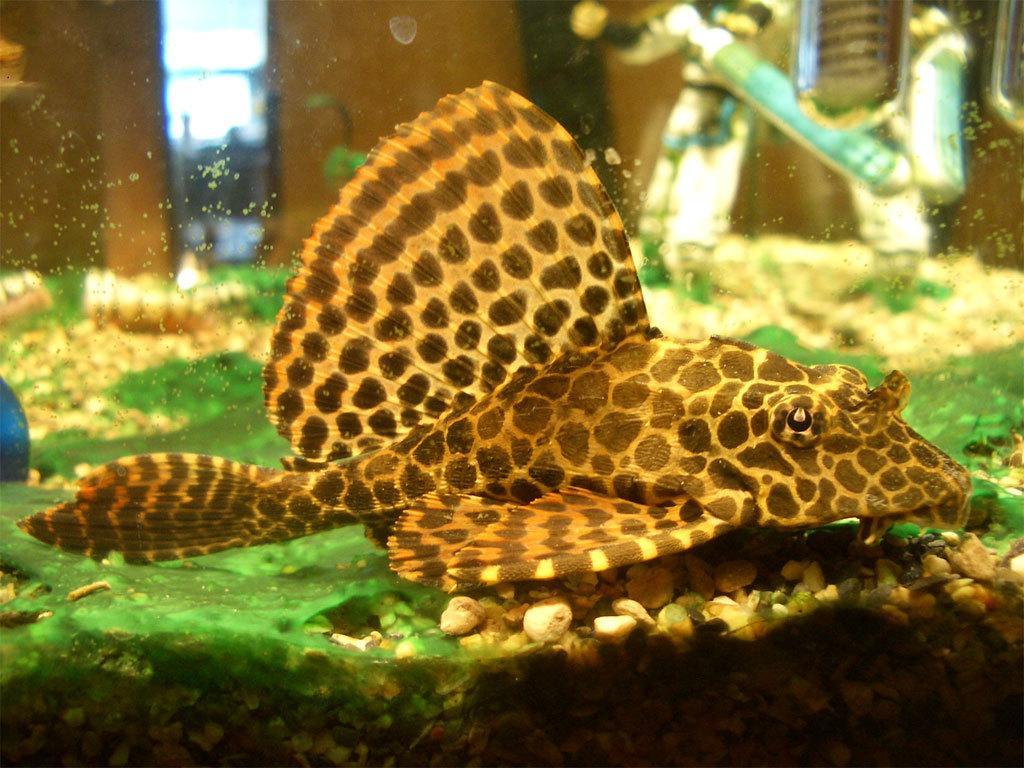How would you summarize this image in a sentence or two? This image looks like an aquarium. And there are stones at the bottom. 